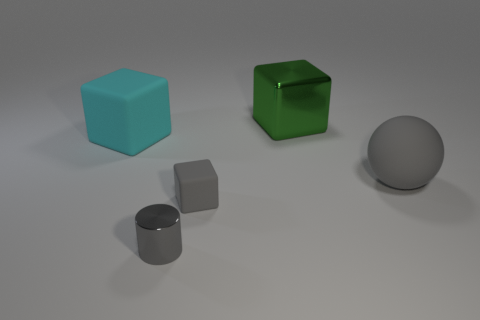How many metal things are the same size as the gray rubber cube?
Provide a short and direct response. 1. The matte thing that is the same color as the tiny cube is what shape?
Keep it short and to the point. Sphere. What is the big green block made of?
Your response must be concise. Metal. There is a thing that is in front of the small block; what size is it?
Your response must be concise. Small. How many other tiny objects are the same shape as the tiny rubber object?
Offer a very short reply. 0. There is another tiny thing that is made of the same material as the cyan thing; what shape is it?
Offer a very short reply. Cube. What number of gray objects are either large rubber balls or small cubes?
Offer a terse response. 2. There is a large gray matte object; are there any gray objects to the left of it?
Make the answer very short. Yes. Do the big matte thing left of the big shiny thing and the small gray shiny thing that is in front of the large cyan cube have the same shape?
Make the answer very short. No. What material is the other large thing that is the same shape as the large cyan matte thing?
Give a very brief answer. Metal. 